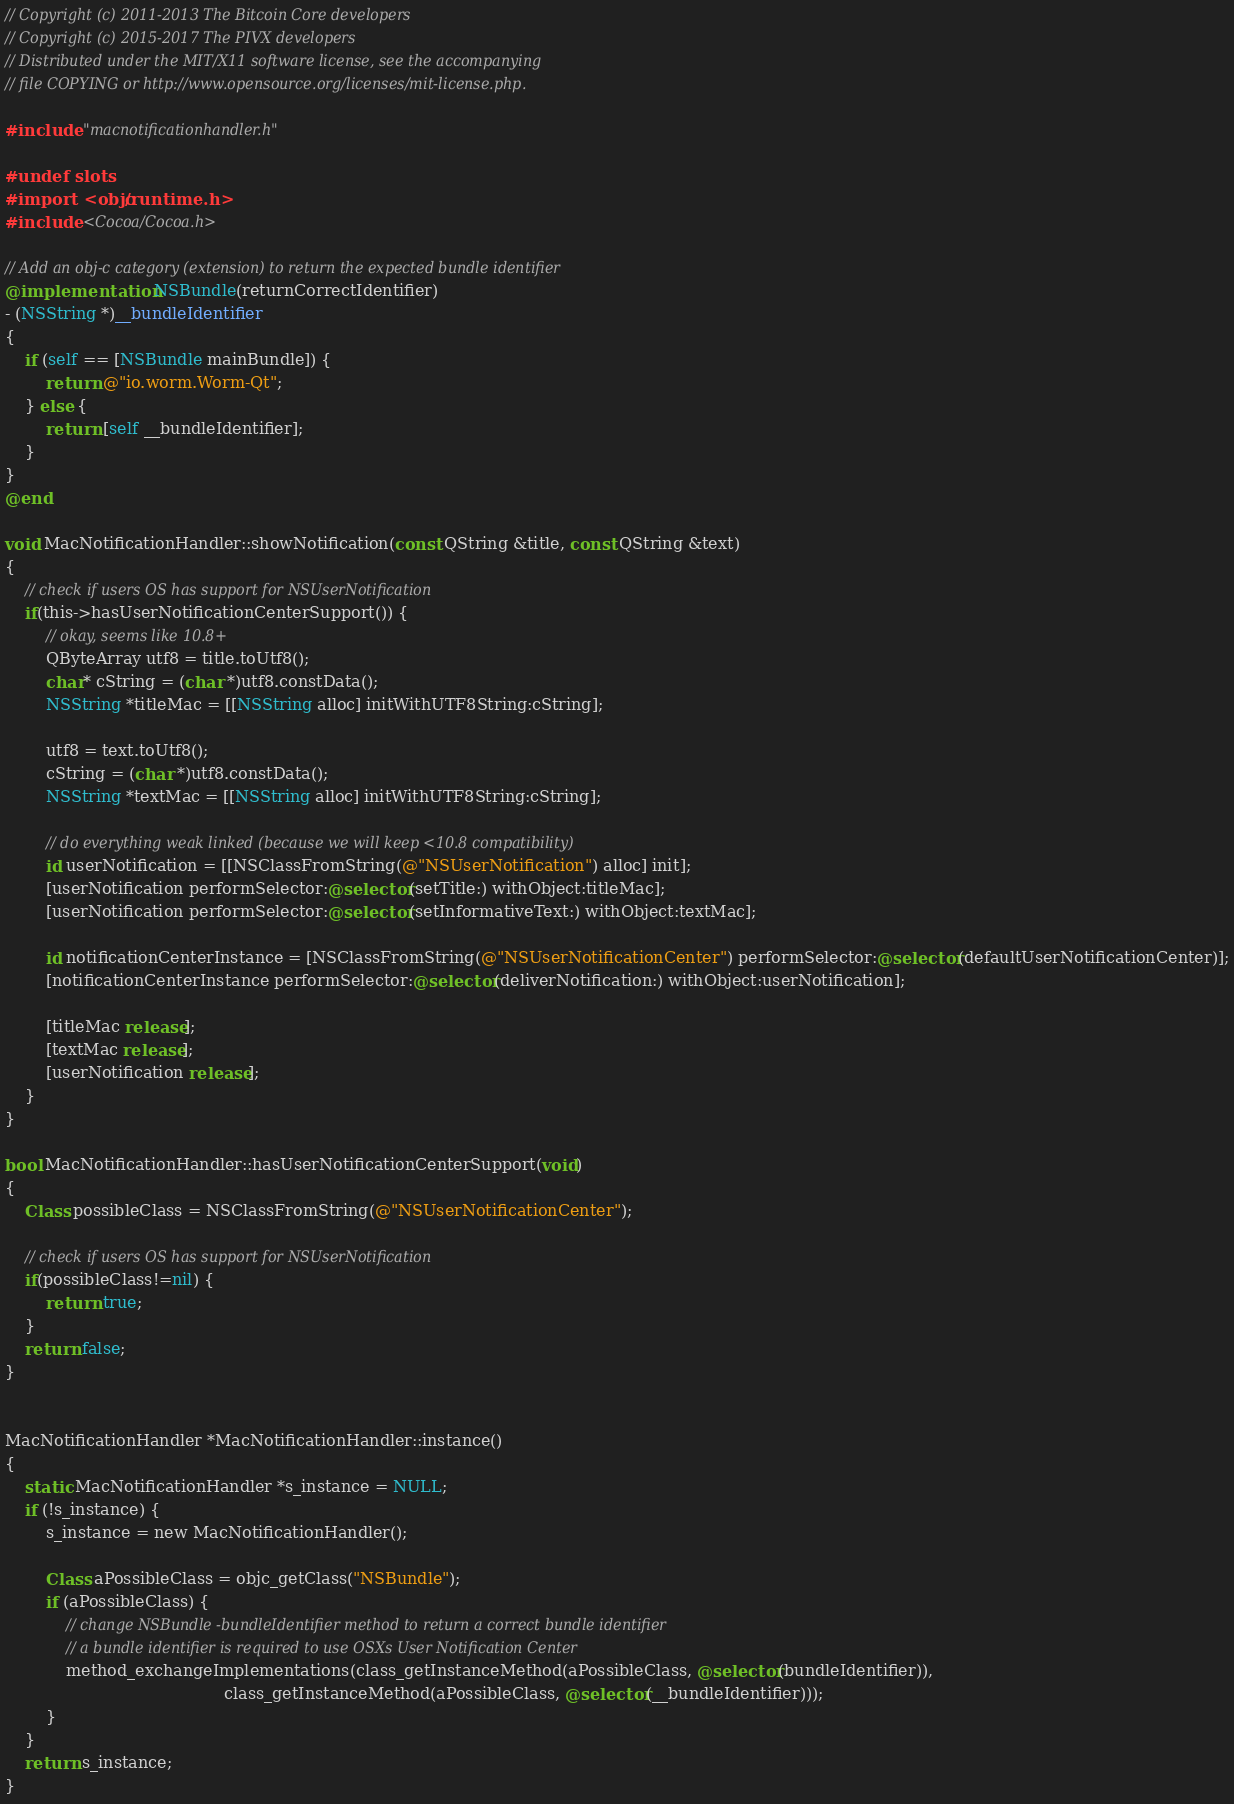<code> <loc_0><loc_0><loc_500><loc_500><_ObjectiveC_>// Copyright (c) 2011-2013 The Bitcoin Core developers
// Copyright (c) 2015-2017 The PIVX developers
// Distributed under the MIT/X11 software license, see the accompanying
// file COPYING or http://www.opensource.org/licenses/mit-license.php.

#include "macnotificationhandler.h"

#undef slots
#import <objc/runtime.h>
#include <Cocoa/Cocoa.h>

// Add an obj-c category (extension) to return the expected bundle identifier
@implementation NSBundle(returnCorrectIdentifier)
- (NSString *)__bundleIdentifier
{
    if (self == [NSBundle mainBundle]) {
        return @"io.worm.Worm-Qt";
    } else {
        return [self __bundleIdentifier];
    }
}
@end

void MacNotificationHandler::showNotification(const QString &title, const QString &text)
{
    // check if users OS has support for NSUserNotification
    if(this->hasUserNotificationCenterSupport()) {
        // okay, seems like 10.8+
        QByteArray utf8 = title.toUtf8();
        char* cString = (char *)utf8.constData();
        NSString *titleMac = [[NSString alloc] initWithUTF8String:cString];

        utf8 = text.toUtf8();
        cString = (char *)utf8.constData();
        NSString *textMac = [[NSString alloc] initWithUTF8String:cString];

        // do everything weak linked (because we will keep <10.8 compatibility)
        id userNotification = [[NSClassFromString(@"NSUserNotification") alloc] init];
        [userNotification performSelector:@selector(setTitle:) withObject:titleMac];
        [userNotification performSelector:@selector(setInformativeText:) withObject:textMac];

        id notificationCenterInstance = [NSClassFromString(@"NSUserNotificationCenter") performSelector:@selector(defaultUserNotificationCenter)];
        [notificationCenterInstance performSelector:@selector(deliverNotification:) withObject:userNotification];

        [titleMac release];
        [textMac release];
        [userNotification release];
    }
}

bool MacNotificationHandler::hasUserNotificationCenterSupport(void)
{
    Class possibleClass = NSClassFromString(@"NSUserNotificationCenter");

    // check if users OS has support for NSUserNotification
    if(possibleClass!=nil) {
        return true;
    }
    return false;
}


MacNotificationHandler *MacNotificationHandler::instance()
{
    static MacNotificationHandler *s_instance = NULL;
    if (!s_instance) {
        s_instance = new MacNotificationHandler();
        
        Class aPossibleClass = objc_getClass("NSBundle");
        if (aPossibleClass) {
            // change NSBundle -bundleIdentifier method to return a correct bundle identifier
            // a bundle identifier is required to use OSXs User Notification Center
            method_exchangeImplementations(class_getInstanceMethod(aPossibleClass, @selector(bundleIdentifier)),
                                           class_getInstanceMethod(aPossibleClass, @selector(__bundleIdentifier)));
        }
    }
    return s_instance;
}
</code> 